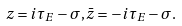<formula> <loc_0><loc_0><loc_500><loc_500>z = i \tau _ { E } - \sigma , \bar { z } = - i \tau _ { E } - \sigma .</formula> 